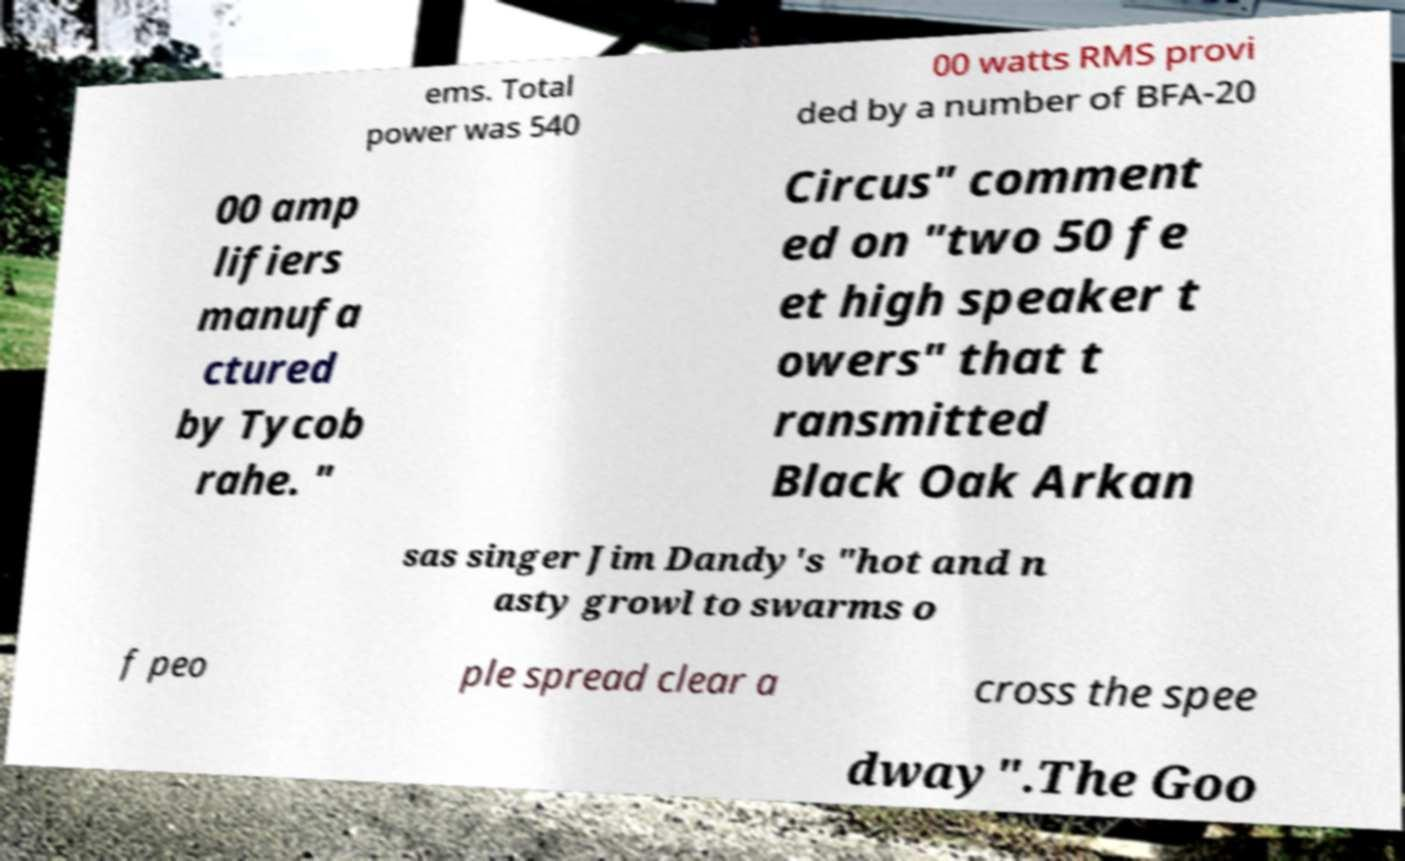For documentation purposes, I need the text within this image transcribed. Could you provide that? ems. Total power was 540 00 watts RMS provi ded by a number of BFA-20 00 amp lifiers manufa ctured by Tycob rahe. " Circus" comment ed on "two 50 fe et high speaker t owers" that t ransmitted Black Oak Arkan sas singer Jim Dandy's "hot and n asty growl to swarms o f peo ple spread clear a cross the spee dway".The Goo 